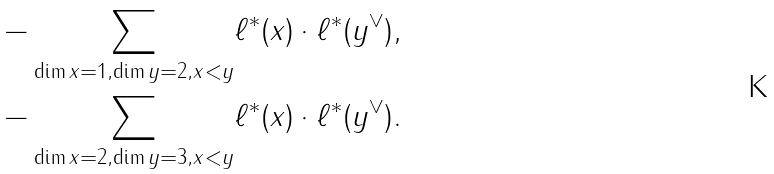Convert formula to latex. <formula><loc_0><loc_0><loc_500><loc_500>- \sum _ { \dim x = 1 , \dim y = 2 , x < y } & \ell ^ { * } ( x ) \cdot \ell ^ { * } ( y ^ { \vee } ) , \\ - \sum _ { \dim x = 2 , \dim y = 3 , x < y } & \ell ^ { * } ( x ) \cdot \ell ^ { * } ( y ^ { \vee } ) .</formula> 